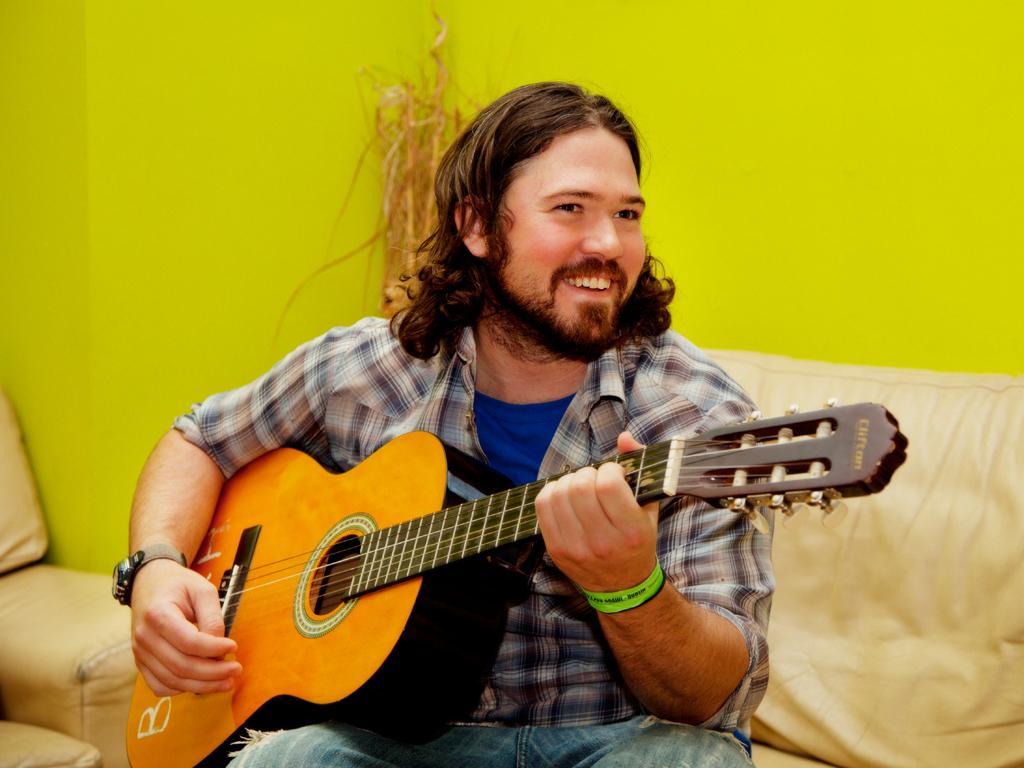In one or two sentences, can you explain what this image depicts? This picture shows a man Seated on the sofa and playing a guitar. 